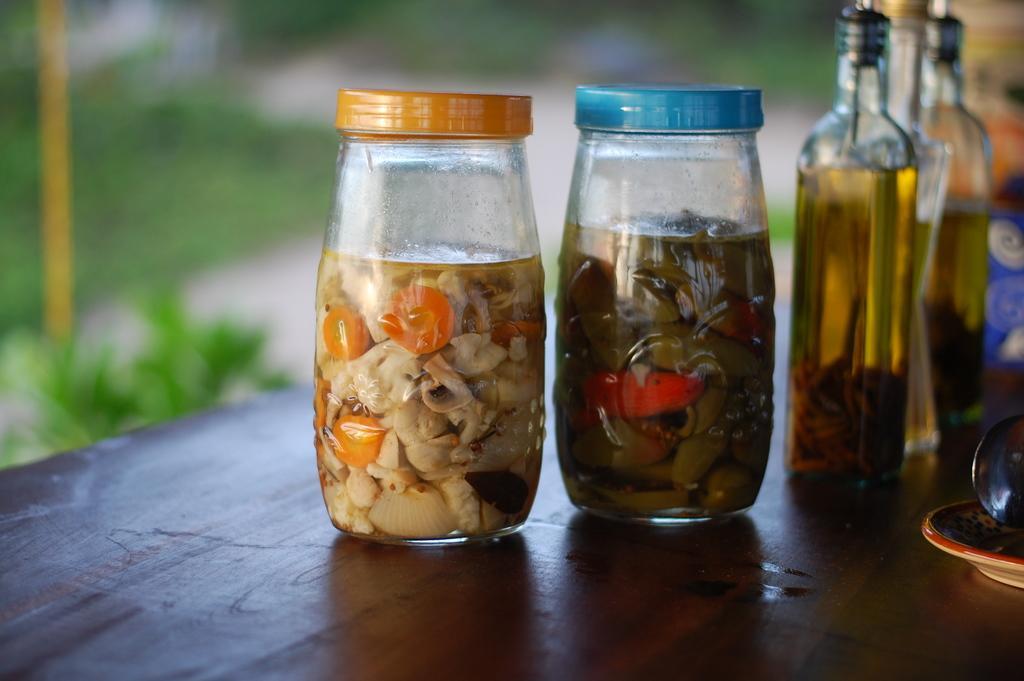In one or two sentences, can you explain what this image depicts? In this picture there are bottles on a table. In the bottles there is storage of food and some bottles these is a liquid. Background of this bottles is a blur. 